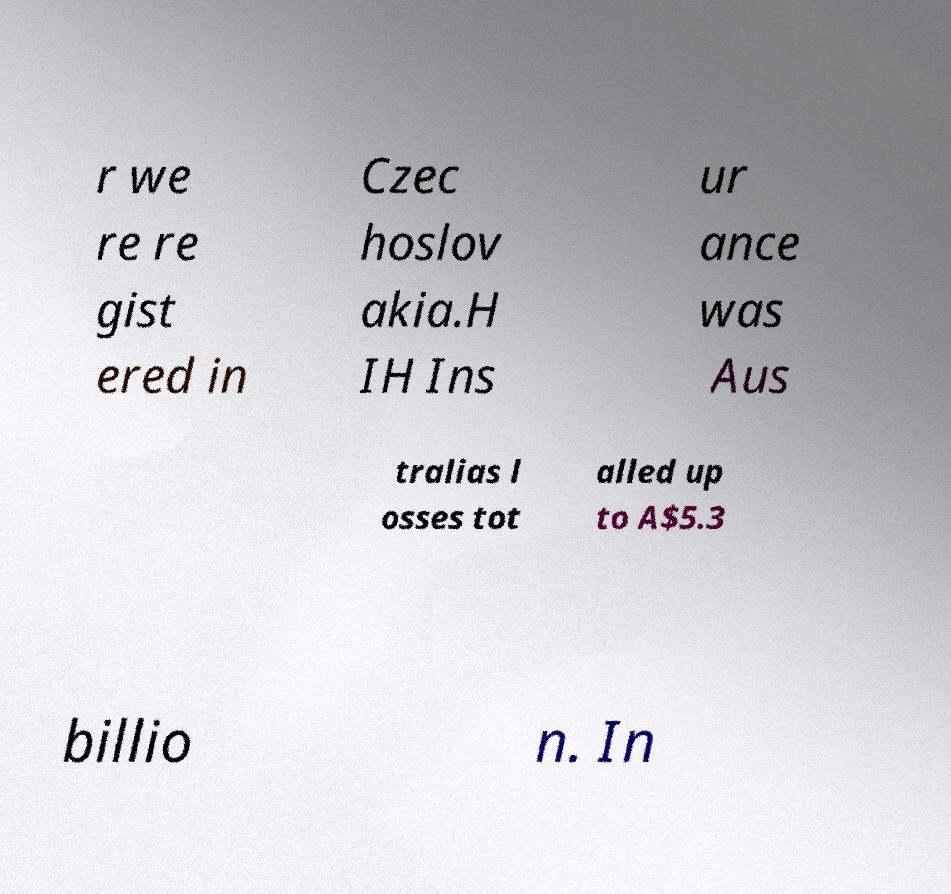Please identify and transcribe the text found in this image. r we re re gist ered in Czec hoslov akia.H IH Ins ur ance was Aus tralias l osses tot alled up to A$5.3 billio n. In 